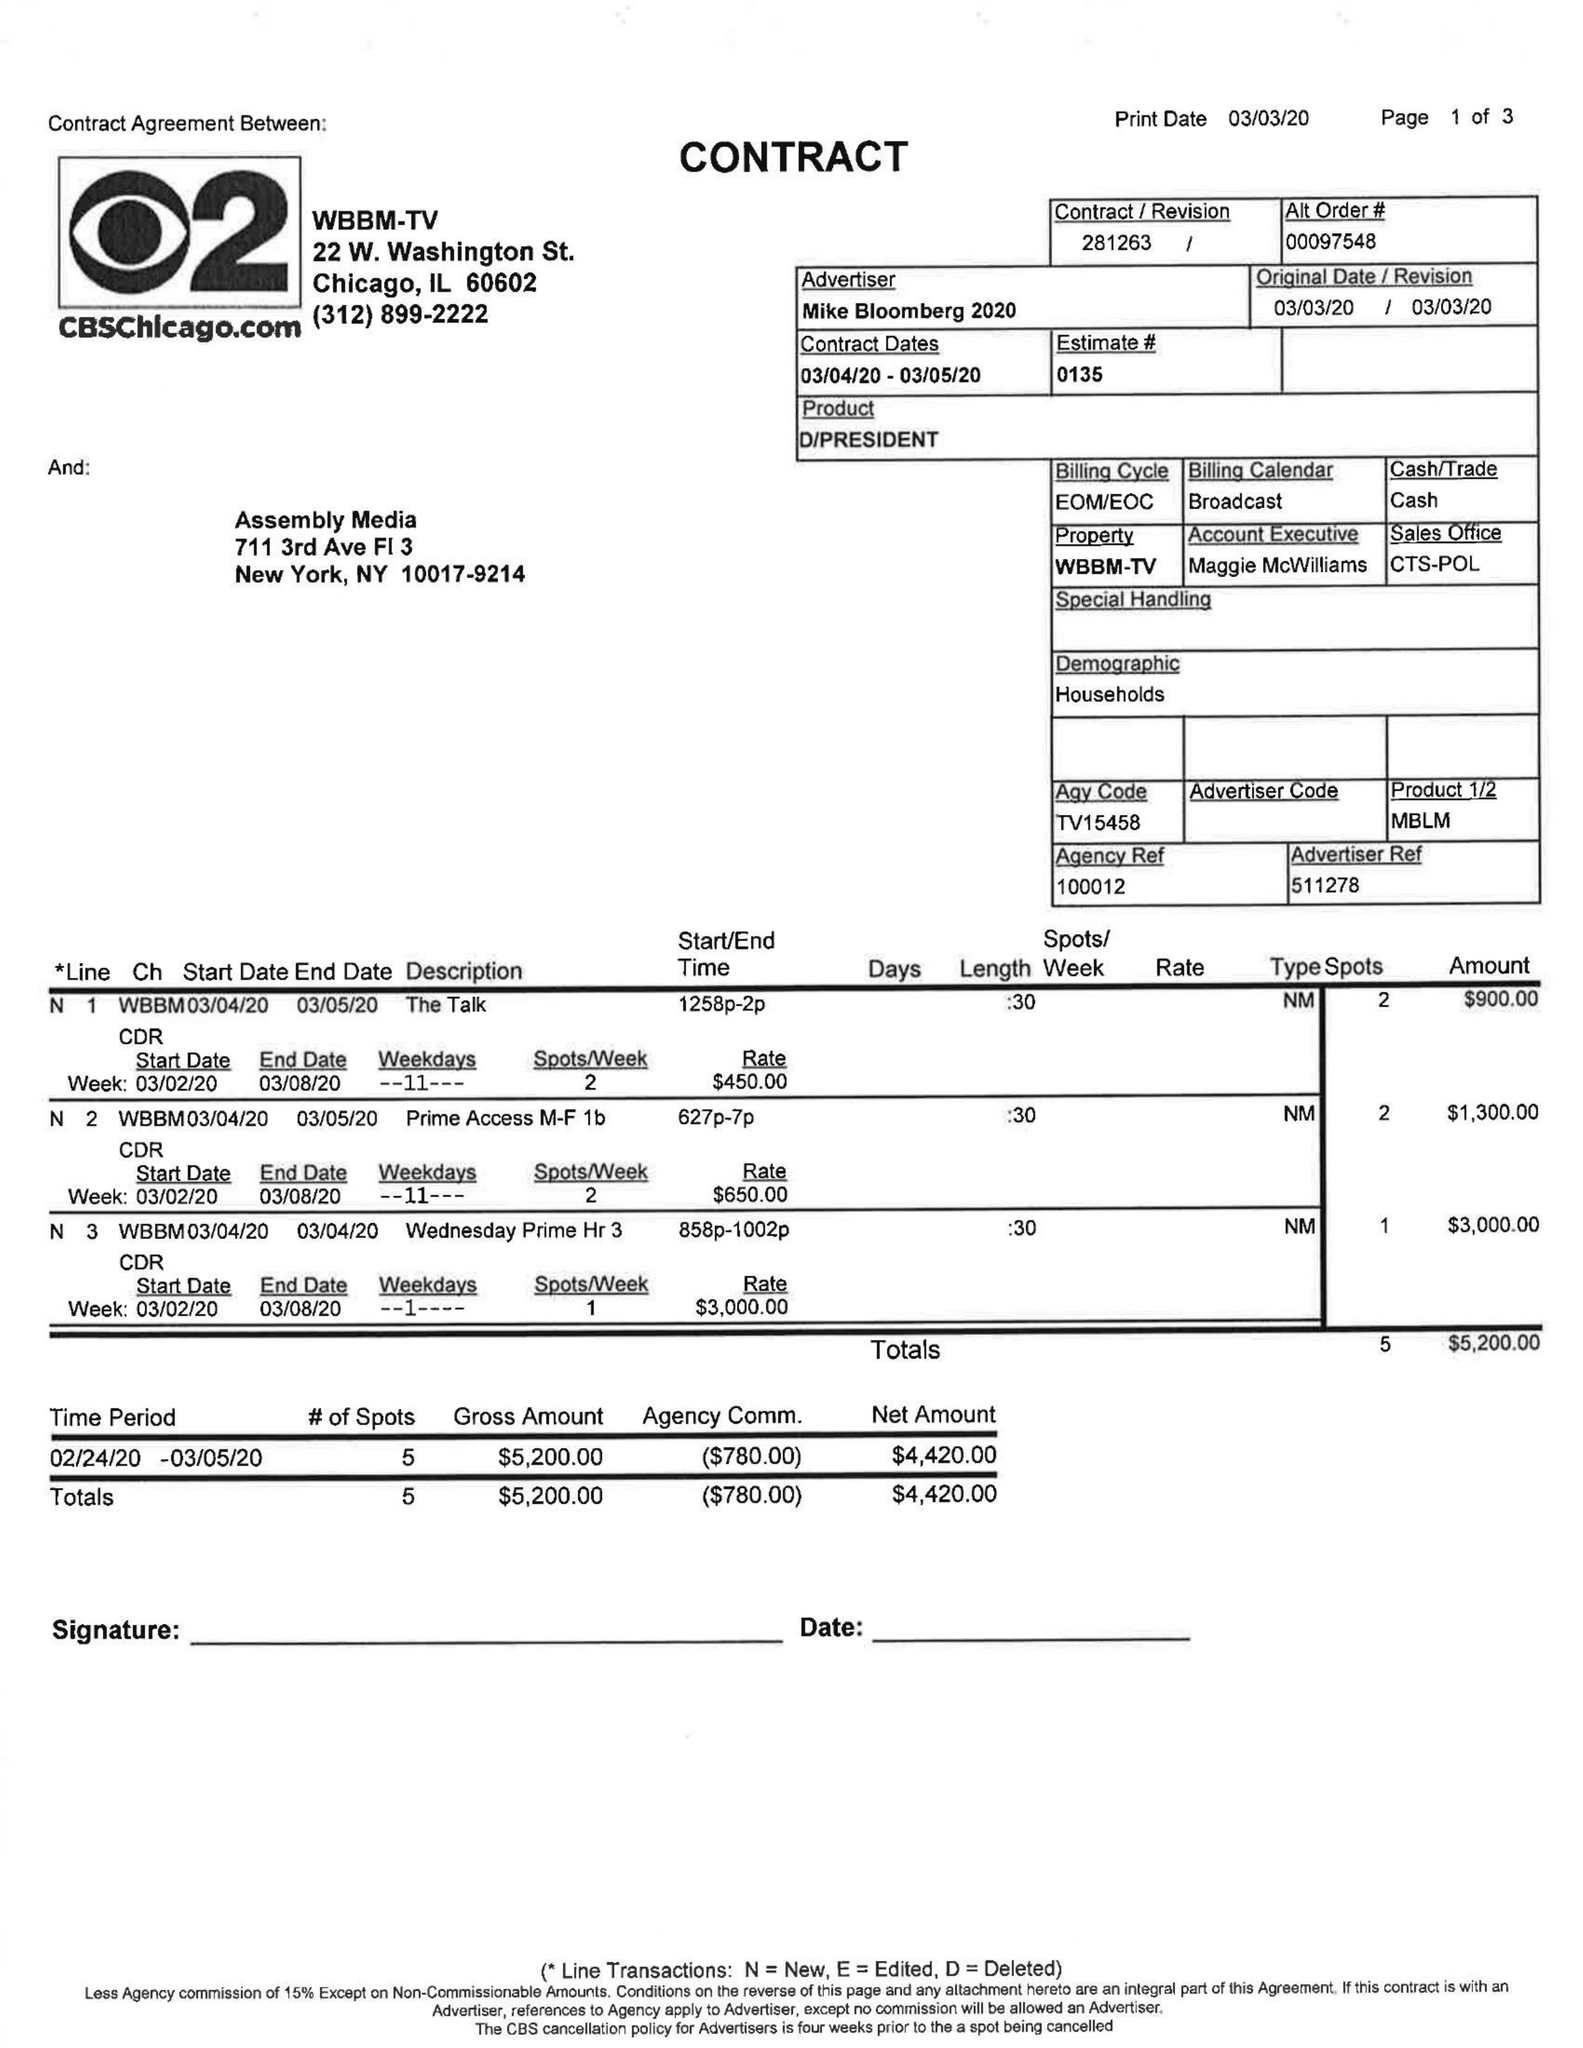What is the value for the flight_to?
Answer the question using a single word or phrase. 03/05/20 